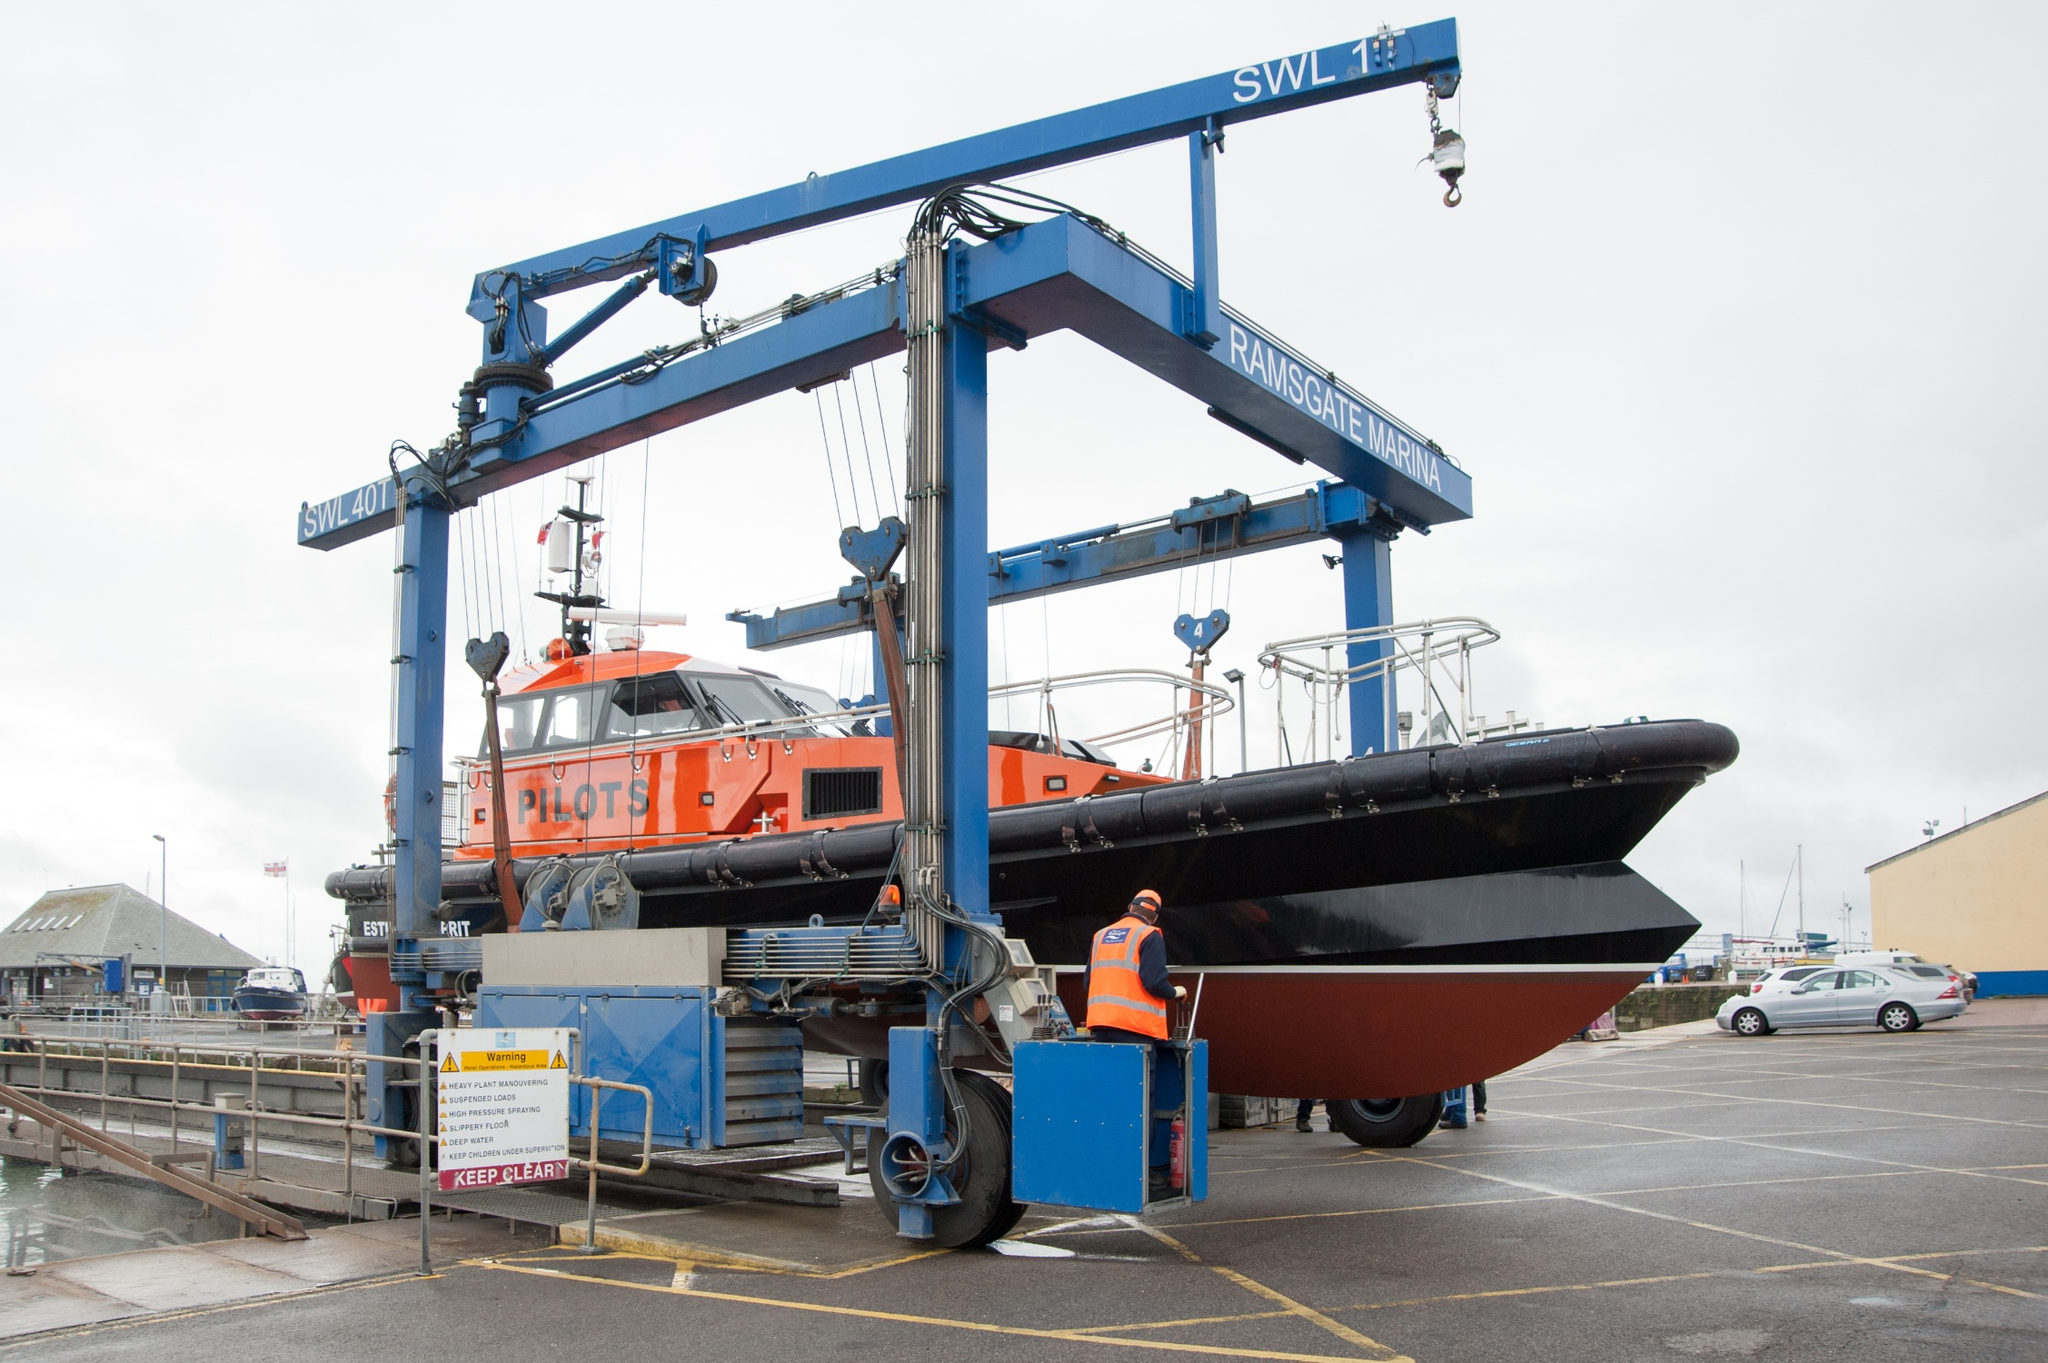How does the crane operate in lifting heavy objects like the boat? The crane operates using a combination of hydraulic and mechanical systems to manage heavy loads. In the case of lifting the pilot boat, the crane uses cables and winches to carefully hoist the boat from the water. These cables are attached at strategic points along the boat's structure to evenly distribute the weight and ensure stability during lifting. The crane operator needs to meticulously control the movement to safely manage the load, keeping it balanced and secure as it transitions from water to air, and eventually over to the landing area. This requires precise coordination and monitoring of the machinery's performance and the load's positioning. 